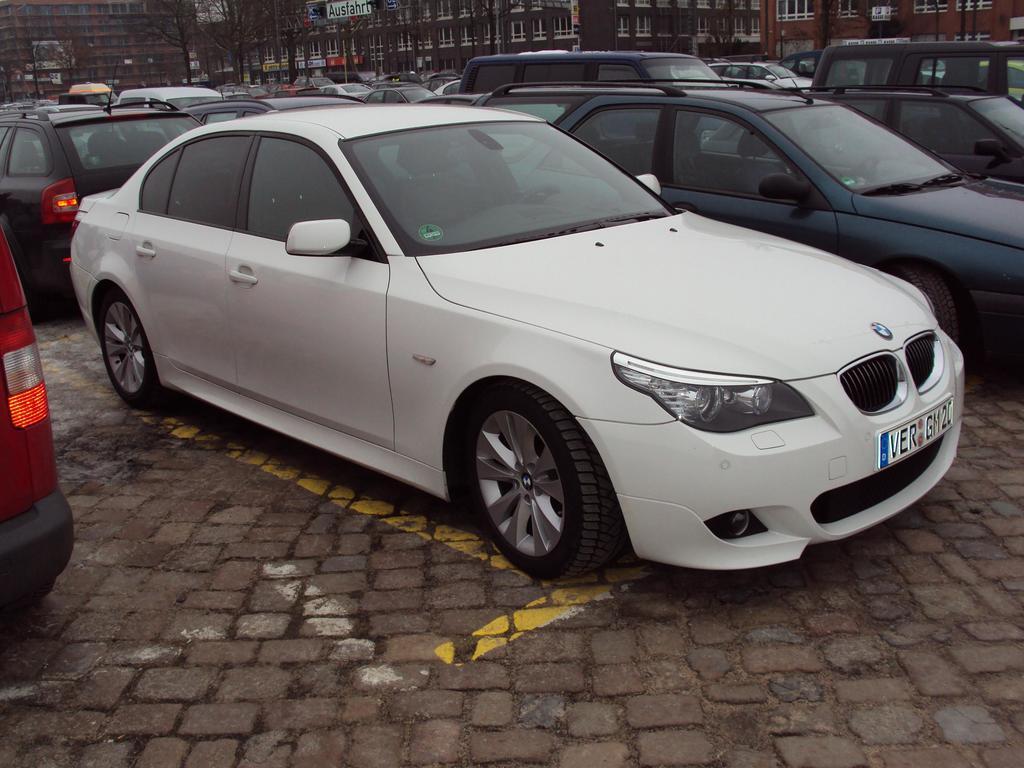In one or two sentences, can you explain what this image depicts? In this picture we can see vehicles on the ground and in the background we can see trees, buildings with windows and some objects. 